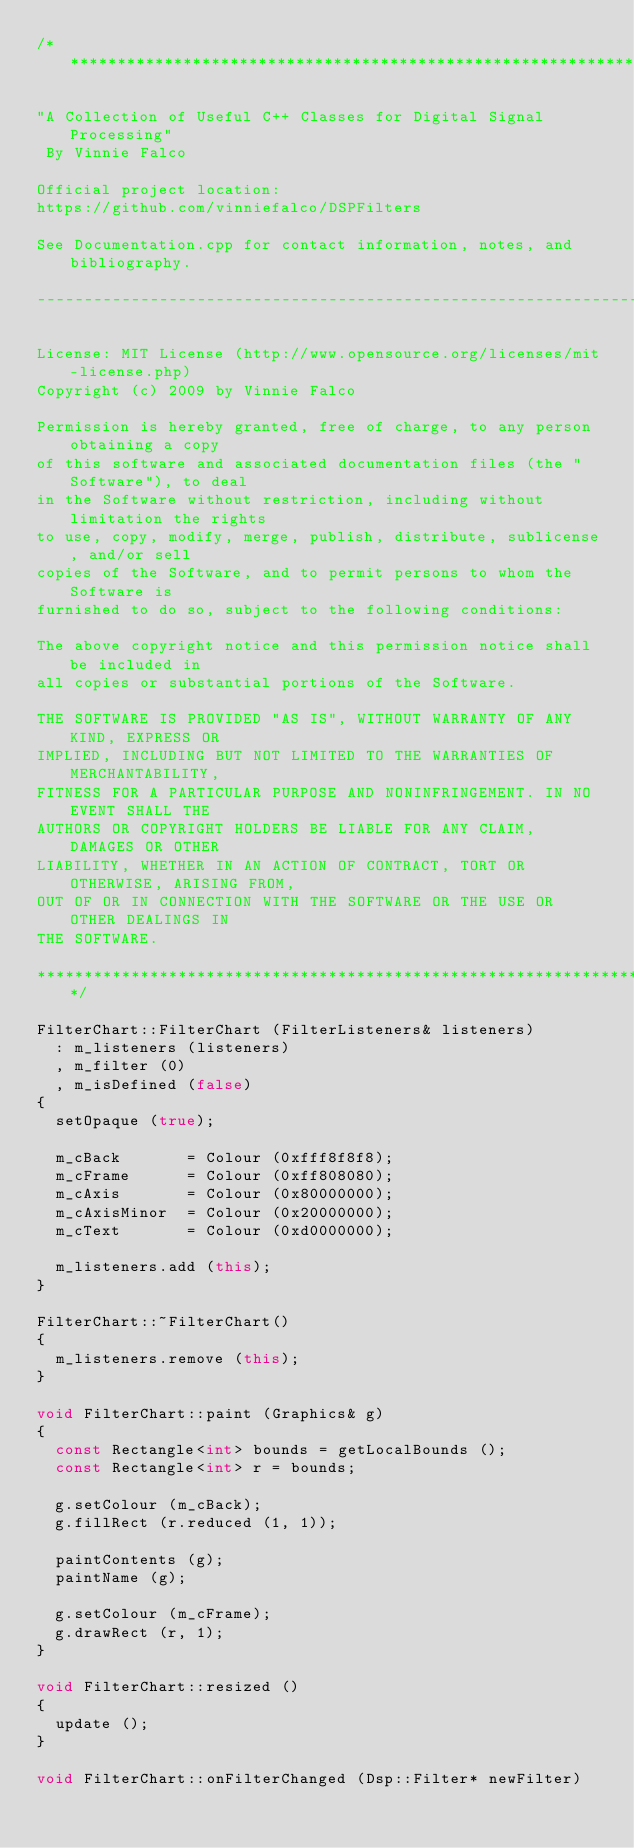<code> <loc_0><loc_0><loc_500><loc_500><_C++_>/*******************************************************************************

"A Collection of Useful C++ Classes for Digital Signal Processing"
 By Vinnie Falco

Official project location:
https://github.com/vinniefalco/DSPFilters

See Documentation.cpp for contact information, notes, and bibliography.

--------------------------------------------------------------------------------

License: MIT License (http://www.opensource.org/licenses/mit-license.php)
Copyright (c) 2009 by Vinnie Falco

Permission is hereby granted, free of charge, to any person obtaining a copy
of this software and associated documentation files (the "Software"), to deal
in the Software without restriction, including without limitation the rights
to use, copy, modify, merge, publish, distribute, sublicense, and/or sell
copies of the Software, and to permit persons to whom the Software is
furnished to do so, subject to the following conditions:

The above copyright notice and this permission notice shall be included in
all copies or substantial portions of the Software.

THE SOFTWARE IS PROVIDED "AS IS", WITHOUT WARRANTY OF ANY KIND, EXPRESS OR
IMPLIED, INCLUDING BUT NOT LIMITED TO THE WARRANTIES OF MERCHANTABILITY,
FITNESS FOR A PARTICULAR PURPOSE AND NONINFRINGEMENT. IN NO EVENT SHALL THE
AUTHORS OR COPYRIGHT HOLDERS BE LIABLE FOR ANY CLAIM, DAMAGES OR OTHER
LIABILITY, WHETHER IN AN ACTION OF CONTRACT, TORT OR OTHERWISE, ARISING FROM,
OUT OF OR IN CONNECTION WITH THE SOFTWARE OR THE USE OR OTHER DEALINGS IN
THE SOFTWARE.

*******************************************************************************/

FilterChart::FilterChart (FilterListeners& listeners)
  : m_listeners (listeners)
  , m_filter (0)
  , m_isDefined (false)
{
  setOpaque (true);

	m_cBack       = Colour (0xfff8f8f8);
	m_cFrame      = Colour (0xff808080);
	m_cAxis       = Colour (0x80000000);
	m_cAxisMinor  = Colour (0x20000000);
	m_cText       = Colour (0xd0000000);

  m_listeners.add (this);
}

FilterChart::~FilterChart()
{
  m_listeners.remove (this);
}

void FilterChart::paint (Graphics& g)
{
  const Rectangle<int> bounds = getLocalBounds ();
	const Rectangle<int> r = bounds;

  g.setColour (m_cBack);
	g.fillRect (r.reduced (1, 1));

  paintContents (g);
  paintName (g);

  g.setColour (m_cFrame);
	g.drawRect (r, 1);
}

void FilterChart::resized ()
{
  update ();
}

void FilterChart::onFilterChanged (Dsp::Filter* newFilter)</code> 